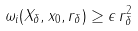Convert formula to latex. <formula><loc_0><loc_0><loc_500><loc_500>\omega _ { i } ( X _ { \delta } , x _ { 0 } , r _ { \delta } ) \geq \epsilon \, r _ { \delta } ^ { 2 }</formula> 